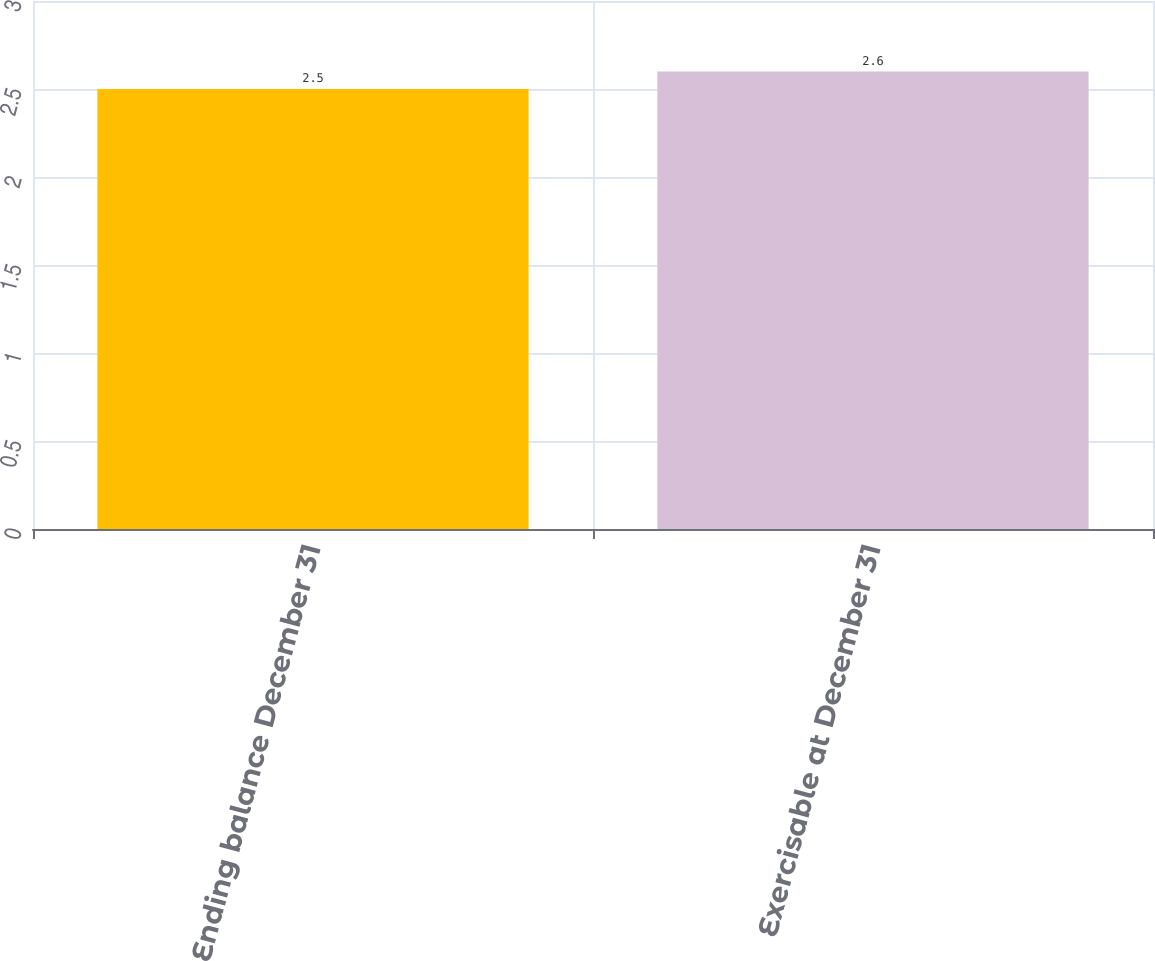Convert chart. <chart><loc_0><loc_0><loc_500><loc_500><bar_chart><fcel>Ending balance December 31<fcel>Exercisable at December 31<nl><fcel>2.5<fcel>2.6<nl></chart> 